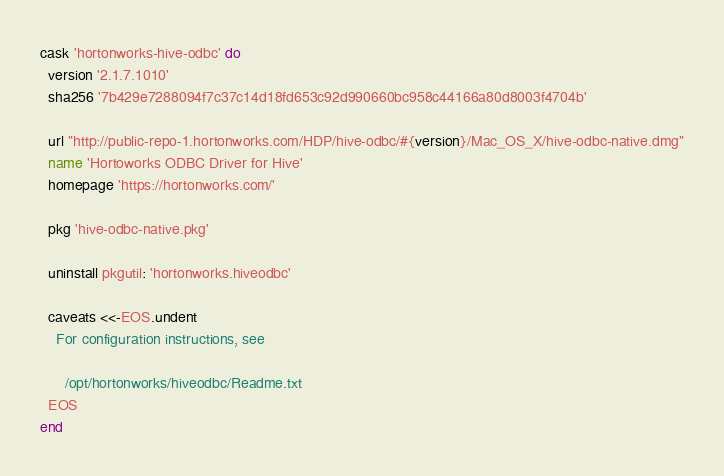Convert code to text. <code><loc_0><loc_0><loc_500><loc_500><_Ruby_>cask 'hortonworks-hive-odbc' do
  version '2.1.7.1010'
  sha256 '7b429e7288094f7c37c14d18fd653c92d990660bc958c44166a80d8003f4704b'

  url "http://public-repo-1.hortonworks.com/HDP/hive-odbc/#{version}/Mac_OS_X/hive-odbc-native.dmg"
  name 'Hortoworks ODBC Driver for Hive'
  homepage 'https://hortonworks.com/'

  pkg 'hive-odbc-native.pkg'

  uninstall pkgutil: 'hortonworks.hiveodbc'

  caveats <<-EOS.undent
    For configuration instructions, see

      /opt/hortonworks/hiveodbc/Readme.txt
  EOS
end
</code> 